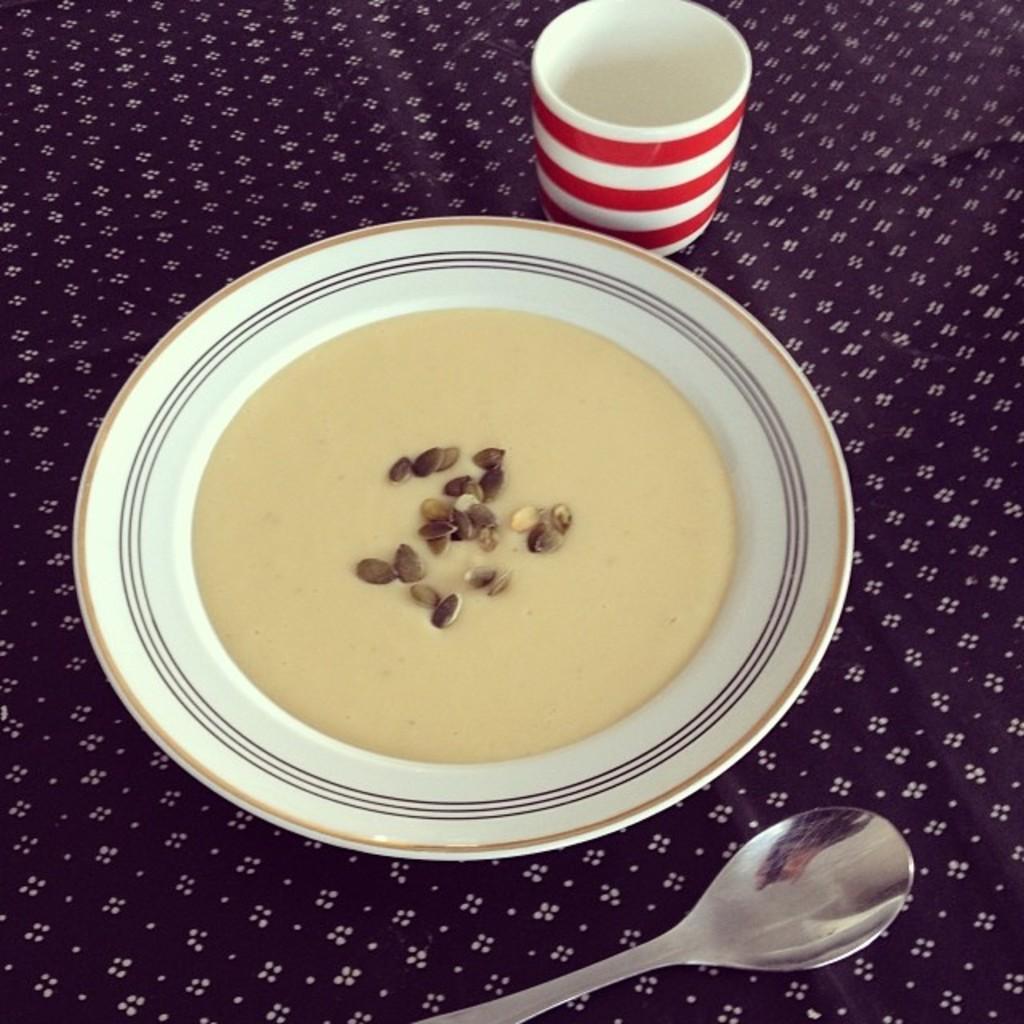Can you describe this image briefly? In the picture I can see one cloth with white design dots. At the top of the cloth I can see one plate behind the plate I can see glass in front of the plate I can see one spoon. 